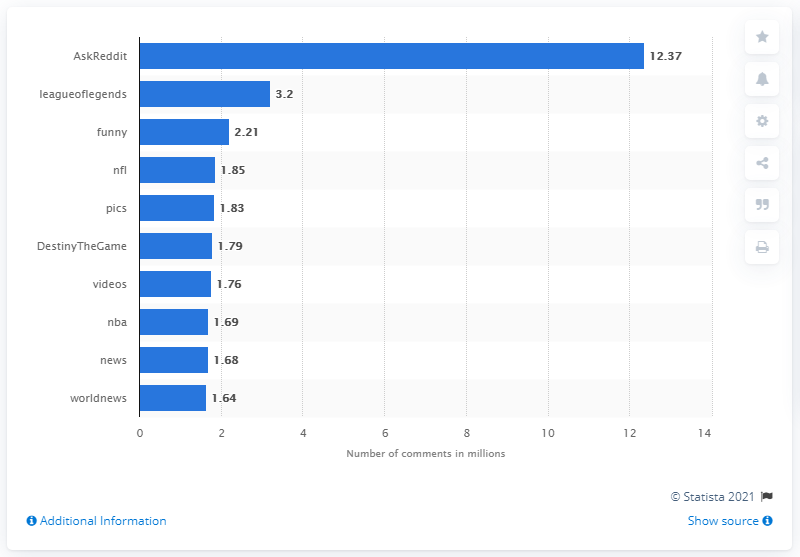Mention a couple of crucial points in this snapshot. The most popular subreddit on Facebook from May to September 2015 was AskReddit. In the period from May to September 2015, AskReddit received a total of 12,370 comments. 